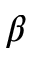<formula> <loc_0><loc_0><loc_500><loc_500>\beta</formula> 